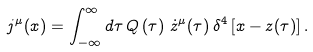<formula> <loc_0><loc_0><loc_500><loc_500>j ^ { \mu } ( x ) = \int ^ { \infty } _ { - \infty } d \tau \, Q \left ( \tau \right ) \, { \dot { z } } ^ { \mu } ( \tau ) \, \delta ^ { 4 } \left [ x - z ( \tau ) \right ] .</formula> 